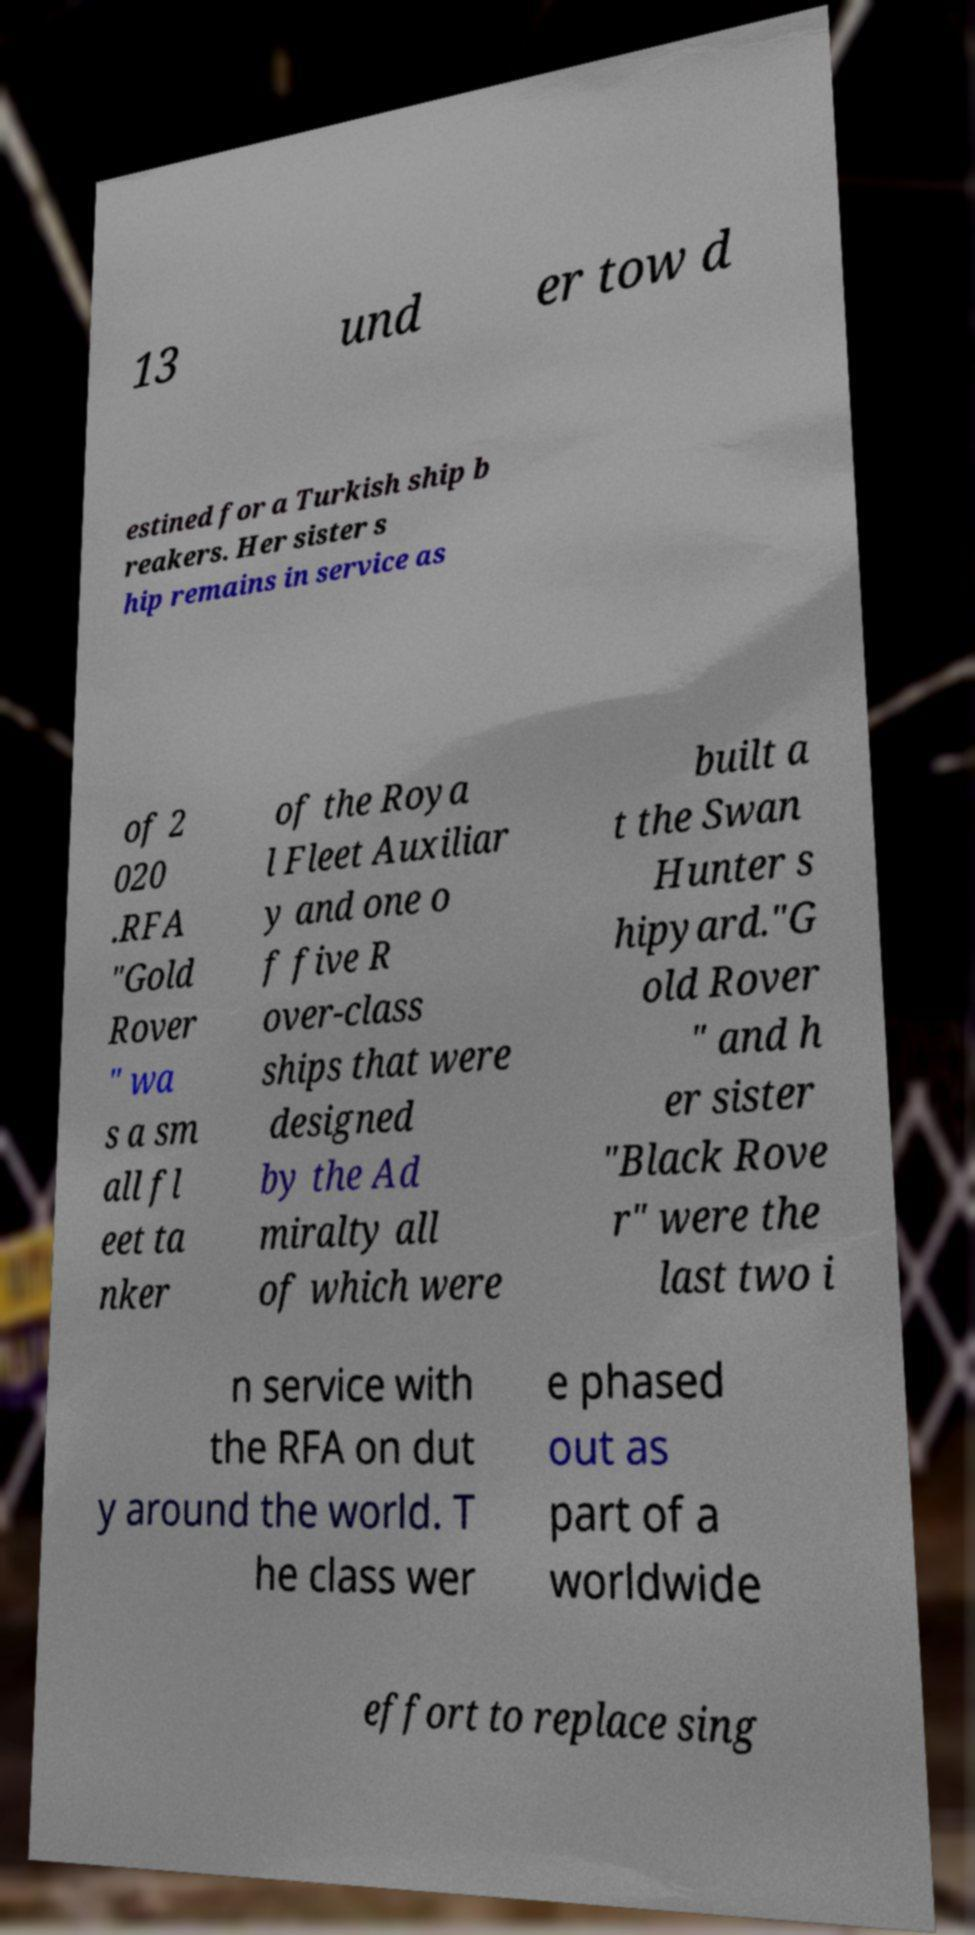Please identify and transcribe the text found in this image. 13 und er tow d estined for a Turkish ship b reakers. Her sister s hip remains in service as of 2 020 .RFA "Gold Rover " wa s a sm all fl eet ta nker of the Roya l Fleet Auxiliar y and one o f five R over-class ships that were designed by the Ad miralty all of which were built a t the Swan Hunter s hipyard."G old Rover " and h er sister "Black Rove r" were the last two i n service with the RFA on dut y around the world. T he class wer e phased out as part of a worldwide effort to replace sing 